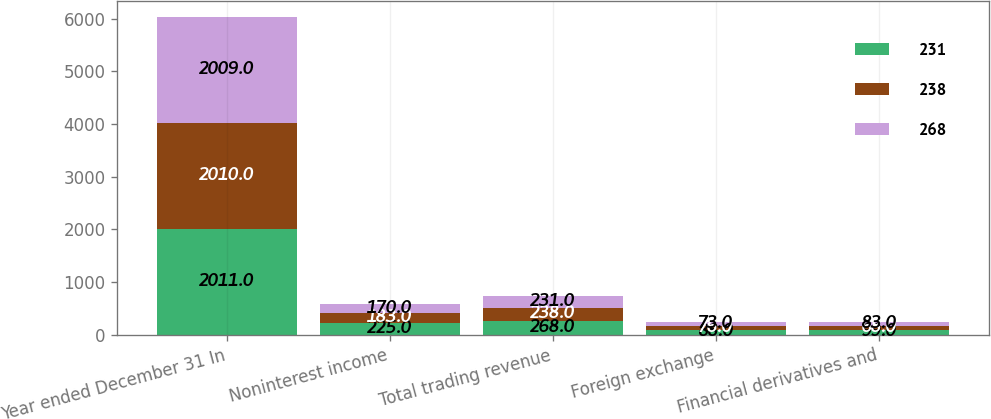Convert chart to OTSL. <chart><loc_0><loc_0><loc_500><loc_500><stacked_bar_chart><ecel><fcel>Year ended December 31 In<fcel>Noninterest income<fcel>Total trading revenue<fcel>Foreign exchange<fcel>Financial derivatives and<nl><fcel>231<fcel>2011<fcel>225<fcel>268<fcel>88<fcel>99<nl><fcel>238<fcel>2010<fcel>183<fcel>238<fcel>76<fcel>68<nl><fcel>268<fcel>2009<fcel>170<fcel>231<fcel>73<fcel>83<nl></chart> 